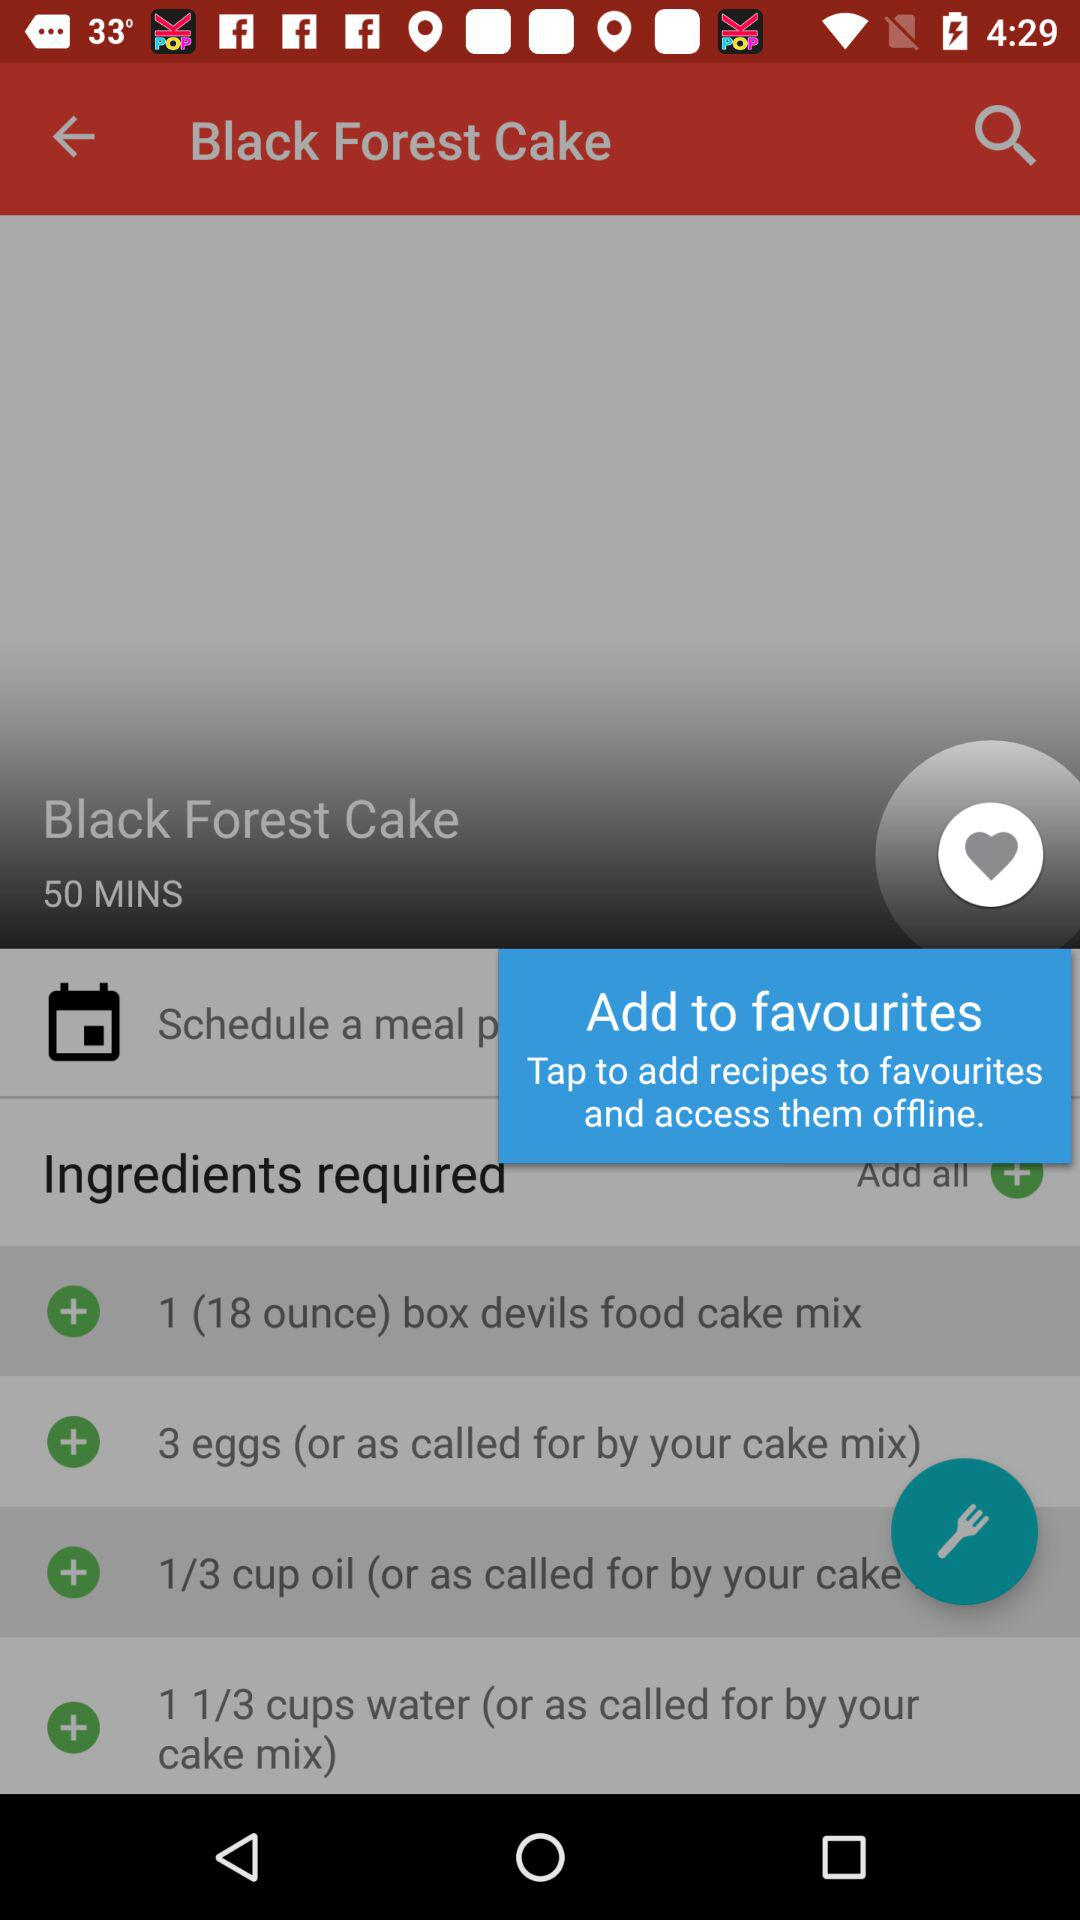How much water was added? The added water was 1 1/3 cups. 